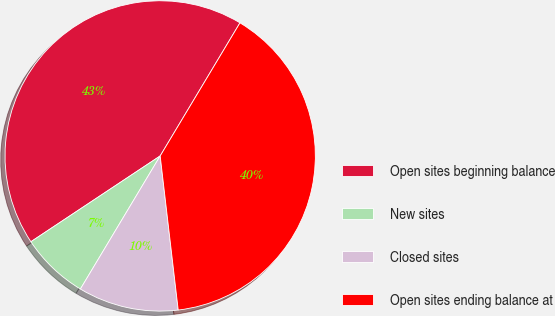Convert chart. <chart><loc_0><loc_0><loc_500><loc_500><pie_chart><fcel>Open sites beginning balance<fcel>New sites<fcel>Closed sites<fcel>Open sites ending balance at<nl><fcel>42.92%<fcel>7.08%<fcel>10.45%<fcel>39.55%<nl></chart> 